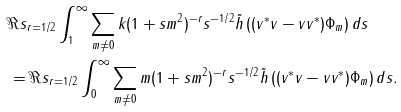<formula> <loc_0><loc_0><loc_500><loc_500>& \Re s _ { r = 1 / 2 } \int _ { 1 } ^ { \infty } \sum _ { m \neq 0 } k ( 1 + s m ^ { 2 } ) ^ { - r } s ^ { - 1 / 2 } \tilde { h } \left ( ( v ^ { * } v - v v ^ { * } ) \Phi _ { m } \right ) d s \\ & = \Re s _ { r = 1 / 2 } \int _ { 0 } ^ { \infty } \sum _ { m \neq 0 } m ( 1 + s m ^ { 2 } ) ^ { - r } s ^ { - 1 / 2 } \tilde { h } \left ( ( v ^ { * } v - v v ^ { * } ) \Phi _ { m } \right ) d s .</formula> 